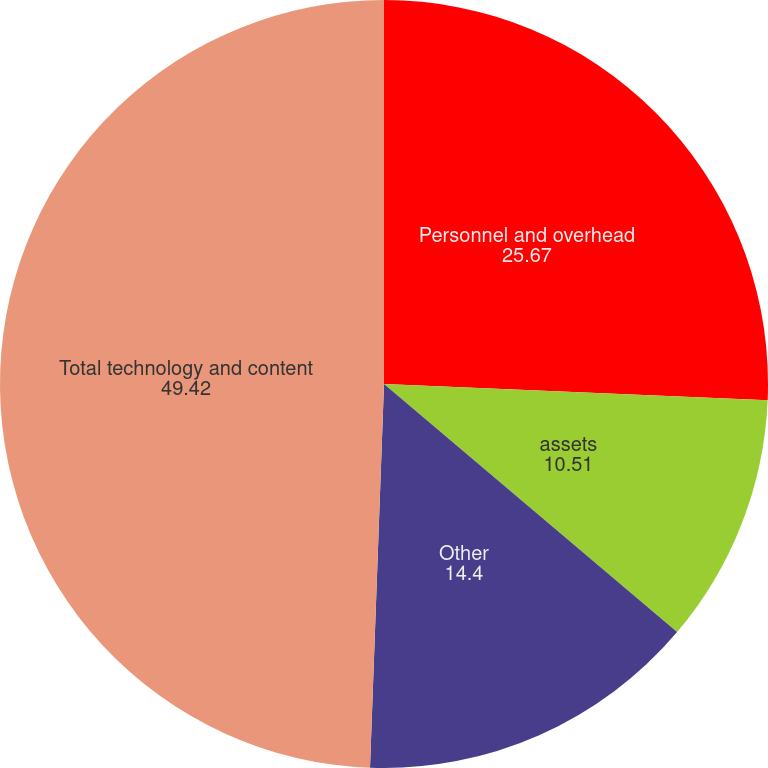Convert chart. <chart><loc_0><loc_0><loc_500><loc_500><pie_chart><fcel>Personnel and overhead<fcel>assets<fcel>Other<fcel>Total technology and content<nl><fcel>25.67%<fcel>10.51%<fcel>14.4%<fcel>49.42%<nl></chart> 